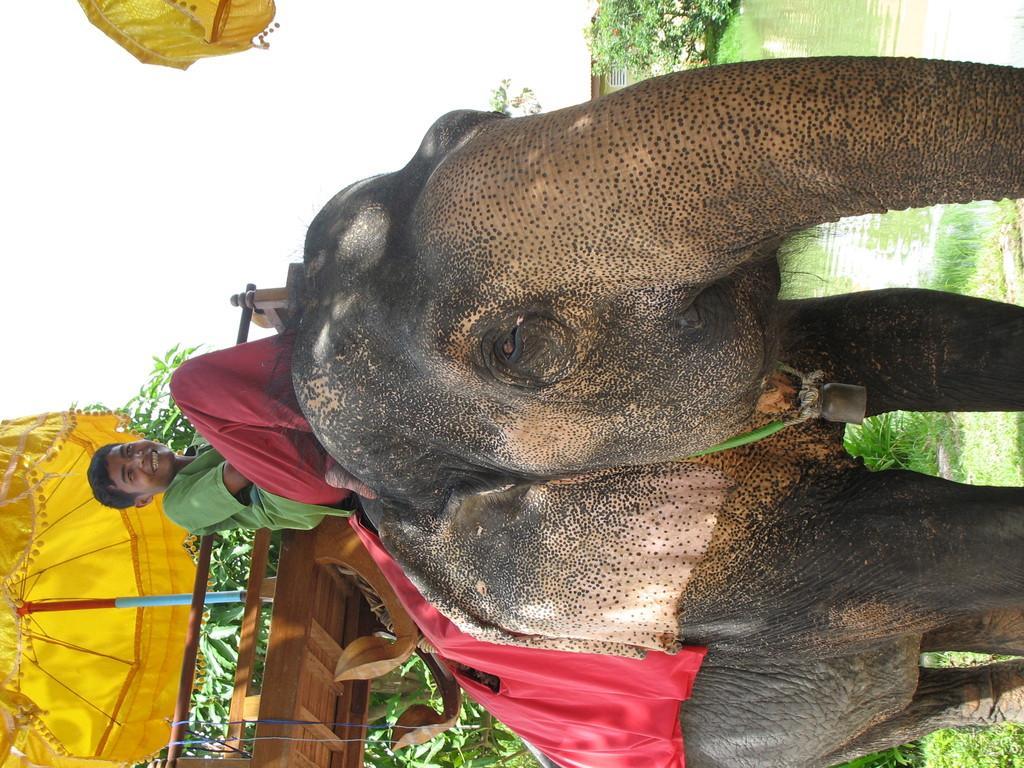How would you summarize this image in a sentence or two? In this picture there is a man who is wearing green t-shirt and he is sitting on the elephant´s back. Here we can see a bell on the elephant neck. On the bottom left corner there is an umbrella on the wooden table. On the top right we can see water near to the trees. On the left we can see sky and clouds. On the bottom we can see trees and grass. 